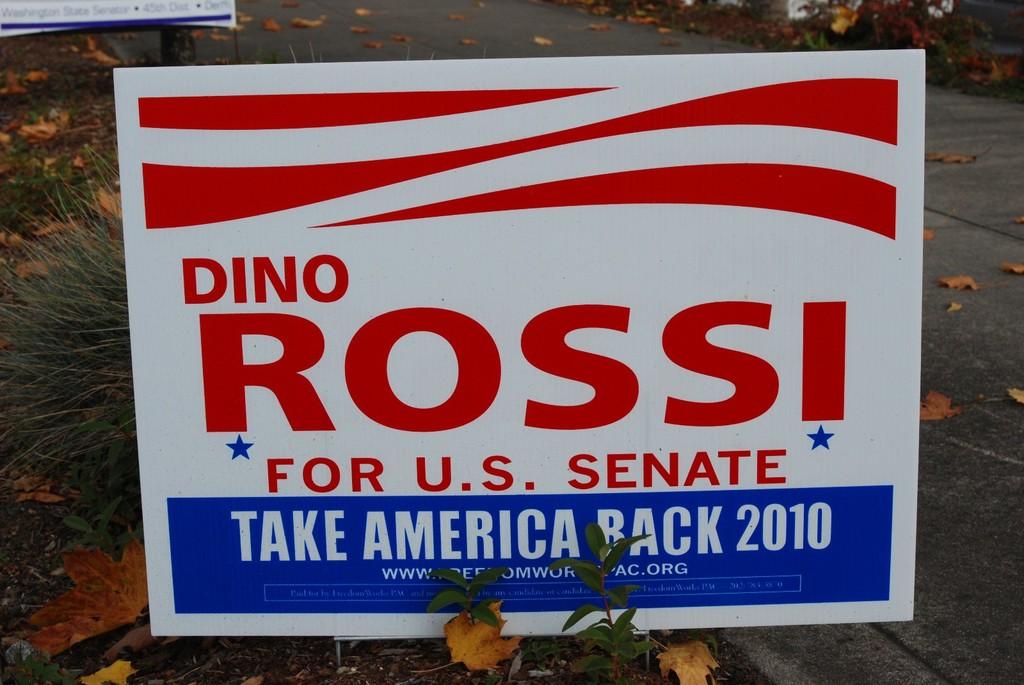Who is running for senate?
Offer a very short reply. Dino rossi. 